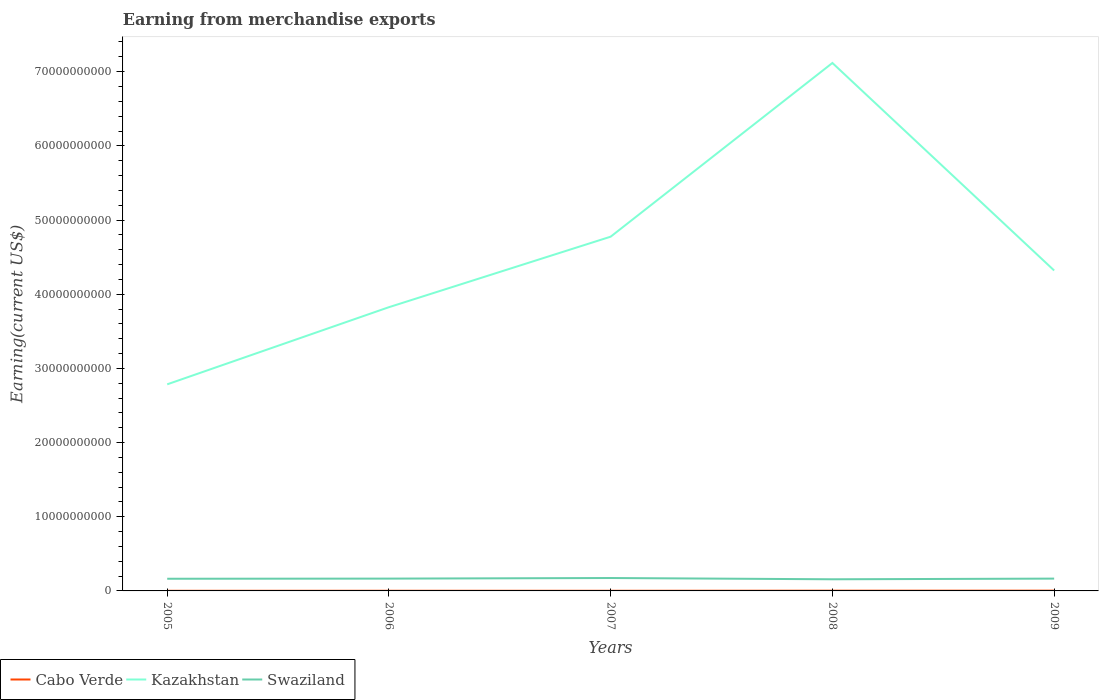Does the line corresponding to Kazakhstan intersect with the line corresponding to Swaziland?
Your response must be concise. No. Across all years, what is the maximum amount earned from merchandise exports in Kazakhstan?
Provide a short and direct response. 2.78e+1. What is the total amount earned from merchandise exports in Swaziland in the graph?
Your response must be concise. 7.00e+07. What is the difference between the highest and the second highest amount earned from merchandise exports in Kazakhstan?
Your answer should be compact. 4.33e+1. Is the amount earned from merchandise exports in Cabo Verde strictly greater than the amount earned from merchandise exports in Kazakhstan over the years?
Offer a terse response. Yes. How many lines are there?
Your answer should be compact. 3. Does the graph contain grids?
Give a very brief answer. No. Where does the legend appear in the graph?
Keep it short and to the point. Bottom left. How many legend labels are there?
Offer a terse response. 3. How are the legend labels stacked?
Your answer should be compact. Horizontal. What is the title of the graph?
Provide a succinct answer. Earning from merchandise exports. Does "High income: OECD" appear as one of the legend labels in the graph?
Your answer should be compact. No. What is the label or title of the Y-axis?
Offer a very short reply. Earning(current US$). What is the Earning(current US$) of Cabo Verde in 2005?
Your answer should be compact. 1.76e+07. What is the Earning(current US$) in Kazakhstan in 2005?
Your response must be concise. 2.78e+1. What is the Earning(current US$) of Swaziland in 2005?
Provide a short and direct response. 1.64e+09. What is the Earning(current US$) of Cabo Verde in 2006?
Ensure brevity in your answer.  2.07e+07. What is the Earning(current US$) in Kazakhstan in 2006?
Ensure brevity in your answer.  3.82e+1. What is the Earning(current US$) in Swaziland in 2006?
Offer a very short reply. 1.66e+09. What is the Earning(current US$) of Cabo Verde in 2007?
Offer a terse response. 1.92e+07. What is the Earning(current US$) in Kazakhstan in 2007?
Your response must be concise. 4.78e+1. What is the Earning(current US$) in Swaziland in 2007?
Keep it short and to the point. 1.74e+09. What is the Earning(current US$) in Cabo Verde in 2008?
Provide a short and direct response. 3.20e+07. What is the Earning(current US$) of Kazakhstan in 2008?
Keep it short and to the point. 7.12e+1. What is the Earning(current US$) in Swaziland in 2008?
Offer a very short reply. 1.57e+09. What is the Earning(current US$) in Cabo Verde in 2009?
Your response must be concise. 3.51e+07. What is the Earning(current US$) of Kazakhstan in 2009?
Your answer should be very brief. 4.32e+1. What is the Earning(current US$) in Swaziland in 2009?
Offer a terse response. 1.66e+09. Across all years, what is the maximum Earning(current US$) of Cabo Verde?
Your response must be concise. 3.51e+07. Across all years, what is the maximum Earning(current US$) in Kazakhstan?
Keep it short and to the point. 7.12e+1. Across all years, what is the maximum Earning(current US$) in Swaziland?
Offer a very short reply. 1.74e+09. Across all years, what is the minimum Earning(current US$) of Cabo Verde?
Your answer should be compact. 1.76e+07. Across all years, what is the minimum Earning(current US$) in Kazakhstan?
Provide a short and direct response. 2.78e+1. Across all years, what is the minimum Earning(current US$) in Swaziland?
Provide a succinct answer. 1.57e+09. What is the total Earning(current US$) in Cabo Verde in the graph?
Provide a succinct answer. 1.25e+08. What is the total Earning(current US$) in Kazakhstan in the graph?
Provide a short and direct response. 2.28e+11. What is the total Earning(current US$) in Swaziland in the graph?
Offer a very short reply. 8.27e+09. What is the difference between the Earning(current US$) of Cabo Verde in 2005 and that in 2006?
Offer a terse response. -3.04e+06. What is the difference between the Earning(current US$) of Kazakhstan in 2005 and that in 2006?
Provide a succinct answer. -1.04e+1. What is the difference between the Earning(current US$) of Swaziland in 2005 and that in 2006?
Give a very brief answer. -2.00e+07. What is the difference between the Earning(current US$) in Cabo Verde in 2005 and that in 2007?
Give a very brief answer. -1.60e+06. What is the difference between the Earning(current US$) in Kazakhstan in 2005 and that in 2007?
Make the answer very short. -1.99e+1. What is the difference between the Earning(current US$) of Swaziland in 2005 and that in 2007?
Offer a terse response. -1.00e+08. What is the difference between the Earning(current US$) of Cabo Verde in 2005 and that in 2008?
Offer a terse response. -1.44e+07. What is the difference between the Earning(current US$) in Kazakhstan in 2005 and that in 2008?
Your answer should be compact. -4.33e+1. What is the difference between the Earning(current US$) of Swaziland in 2005 and that in 2008?
Keep it short and to the point. 7.00e+07. What is the difference between the Earning(current US$) of Cabo Verde in 2005 and that in 2009?
Offer a very short reply. -1.75e+07. What is the difference between the Earning(current US$) in Kazakhstan in 2005 and that in 2009?
Your answer should be compact. -1.53e+1. What is the difference between the Earning(current US$) in Swaziland in 2005 and that in 2009?
Keep it short and to the point. -2.00e+07. What is the difference between the Earning(current US$) in Cabo Verde in 2006 and that in 2007?
Make the answer very short. 1.43e+06. What is the difference between the Earning(current US$) of Kazakhstan in 2006 and that in 2007?
Offer a very short reply. -9.50e+09. What is the difference between the Earning(current US$) of Swaziland in 2006 and that in 2007?
Keep it short and to the point. -8.00e+07. What is the difference between the Earning(current US$) of Cabo Verde in 2006 and that in 2008?
Your answer should be compact. -1.13e+07. What is the difference between the Earning(current US$) in Kazakhstan in 2006 and that in 2008?
Ensure brevity in your answer.  -3.29e+1. What is the difference between the Earning(current US$) in Swaziland in 2006 and that in 2008?
Offer a very short reply. 9.00e+07. What is the difference between the Earning(current US$) of Cabo Verde in 2006 and that in 2009?
Provide a succinct answer. -1.45e+07. What is the difference between the Earning(current US$) in Kazakhstan in 2006 and that in 2009?
Offer a terse response. -4.95e+09. What is the difference between the Earning(current US$) of Cabo Verde in 2007 and that in 2008?
Provide a short and direct response. -1.28e+07. What is the difference between the Earning(current US$) in Kazakhstan in 2007 and that in 2008?
Keep it short and to the point. -2.34e+1. What is the difference between the Earning(current US$) in Swaziland in 2007 and that in 2008?
Your response must be concise. 1.70e+08. What is the difference between the Earning(current US$) in Cabo Verde in 2007 and that in 2009?
Give a very brief answer. -1.59e+07. What is the difference between the Earning(current US$) in Kazakhstan in 2007 and that in 2009?
Make the answer very short. 4.56e+09. What is the difference between the Earning(current US$) of Swaziland in 2007 and that in 2009?
Offer a very short reply. 8.00e+07. What is the difference between the Earning(current US$) of Cabo Verde in 2008 and that in 2009?
Your answer should be compact. -3.14e+06. What is the difference between the Earning(current US$) in Kazakhstan in 2008 and that in 2009?
Your answer should be very brief. 2.80e+1. What is the difference between the Earning(current US$) of Swaziland in 2008 and that in 2009?
Make the answer very short. -9.00e+07. What is the difference between the Earning(current US$) of Cabo Verde in 2005 and the Earning(current US$) of Kazakhstan in 2006?
Offer a terse response. -3.82e+1. What is the difference between the Earning(current US$) of Cabo Verde in 2005 and the Earning(current US$) of Swaziland in 2006?
Make the answer very short. -1.64e+09. What is the difference between the Earning(current US$) in Kazakhstan in 2005 and the Earning(current US$) in Swaziland in 2006?
Offer a terse response. 2.62e+1. What is the difference between the Earning(current US$) of Cabo Verde in 2005 and the Earning(current US$) of Kazakhstan in 2007?
Ensure brevity in your answer.  -4.77e+1. What is the difference between the Earning(current US$) in Cabo Verde in 2005 and the Earning(current US$) in Swaziland in 2007?
Your answer should be very brief. -1.72e+09. What is the difference between the Earning(current US$) in Kazakhstan in 2005 and the Earning(current US$) in Swaziland in 2007?
Your answer should be compact. 2.61e+1. What is the difference between the Earning(current US$) in Cabo Verde in 2005 and the Earning(current US$) in Kazakhstan in 2008?
Your answer should be very brief. -7.12e+1. What is the difference between the Earning(current US$) in Cabo Verde in 2005 and the Earning(current US$) in Swaziland in 2008?
Offer a very short reply. -1.55e+09. What is the difference between the Earning(current US$) in Kazakhstan in 2005 and the Earning(current US$) in Swaziland in 2008?
Give a very brief answer. 2.63e+1. What is the difference between the Earning(current US$) in Cabo Verde in 2005 and the Earning(current US$) in Kazakhstan in 2009?
Make the answer very short. -4.32e+1. What is the difference between the Earning(current US$) in Cabo Verde in 2005 and the Earning(current US$) in Swaziland in 2009?
Your response must be concise. -1.64e+09. What is the difference between the Earning(current US$) in Kazakhstan in 2005 and the Earning(current US$) in Swaziland in 2009?
Your response must be concise. 2.62e+1. What is the difference between the Earning(current US$) in Cabo Verde in 2006 and the Earning(current US$) in Kazakhstan in 2007?
Your answer should be very brief. -4.77e+1. What is the difference between the Earning(current US$) in Cabo Verde in 2006 and the Earning(current US$) in Swaziland in 2007?
Make the answer very short. -1.72e+09. What is the difference between the Earning(current US$) in Kazakhstan in 2006 and the Earning(current US$) in Swaziland in 2007?
Provide a short and direct response. 3.65e+1. What is the difference between the Earning(current US$) of Cabo Verde in 2006 and the Earning(current US$) of Kazakhstan in 2008?
Offer a terse response. -7.12e+1. What is the difference between the Earning(current US$) of Cabo Verde in 2006 and the Earning(current US$) of Swaziland in 2008?
Your answer should be very brief. -1.55e+09. What is the difference between the Earning(current US$) in Kazakhstan in 2006 and the Earning(current US$) in Swaziland in 2008?
Make the answer very short. 3.67e+1. What is the difference between the Earning(current US$) of Cabo Verde in 2006 and the Earning(current US$) of Kazakhstan in 2009?
Offer a very short reply. -4.32e+1. What is the difference between the Earning(current US$) of Cabo Verde in 2006 and the Earning(current US$) of Swaziland in 2009?
Offer a terse response. -1.64e+09. What is the difference between the Earning(current US$) of Kazakhstan in 2006 and the Earning(current US$) of Swaziland in 2009?
Provide a short and direct response. 3.66e+1. What is the difference between the Earning(current US$) of Cabo Verde in 2007 and the Earning(current US$) of Kazakhstan in 2008?
Offer a terse response. -7.12e+1. What is the difference between the Earning(current US$) of Cabo Verde in 2007 and the Earning(current US$) of Swaziland in 2008?
Offer a terse response. -1.55e+09. What is the difference between the Earning(current US$) of Kazakhstan in 2007 and the Earning(current US$) of Swaziland in 2008?
Keep it short and to the point. 4.62e+1. What is the difference between the Earning(current US$) in Cabo Verde in 2007 and the Earning(current US$) in Kazakhstan in 2009?
Provide a succinct answer. -4.32e+1. What is the difference between the Earning(current US$) in Cabo Verde in 2007 and the Earning(current US$) in Swaziland in 2009?
Your response must be concise. -1.64e+09. What is the difference between the Earning(current US$) of Kazakhstan in 2007 and the Earning(current US$) of Swaziland in 2009?
Provide a succinct answer. 4.61e+1. What is the difference between the Earning(current US$) of Cabo Verde in 2008 and the Earning(current US$) of Kazakhstan in 2009?
Ensure brevity in your answer.  -4.32e+1. What is the difference between the Earning(current US$) of Cabo Verde in 2008 and the Earning(current US$) of Swaziland in 2009?
Your answer should be compact. -1.63e+09. What is the difference between the Earning(current US$) in Kazakhstan in 2008 and the Earning(current US$) in Swaziland in 2009?
Provide a succinct answer. 6.95e+1. What is the average Earning(current US$) of Cabo Verde per year?
Your answer should be very brief. 2.49e+07. What is the average Earning(current US$) of Kazakhstan per year?
Provide a succinct answer. 4.56e+1. What is the average Earning(current US$) of Swaziland per year?
Provide a short and direct response. 1.65e+09. In the year 2005, what is the difference between the Earning(current US$) of Cabo Verde and Earning(current US$) of Kazakhstan?
Make the answer very short. -2.78e+1. In the year 2005, what is the difference between the Earning(current US$) of Cabo Verde and Earning(current US$) of Swaziland?
Ensure brevity in your answer.  -1.62e+09. In the year 2005, what is the difference between the Earning(current US$) of Kazakhstan and Earning(current US$) of Swaziland?
Make the answer very short. 2.62e+1. In the year 2006, what is the difference between the Earning(current US$) in Cabo Verde and Earning(current US$) in Kazakhstan?
Offer a very short reply. -3.82e+1. In the year 2006, what is the difference between the Earning(current US$) in Cabo Verde and Earning(current US$) in Swaziland?
Offer a very short reply. -1.64e+09. In the year 2006, what is the difference between the Earning(current US$) of Kazakhstan and Earning(current US$) of Swaziland?
Ensure brevity in your answer.  3.66e+1. In the year 2007, what is the difference between the Earning(current US$) of Cabo Verde and Earning(current US$) of Kazakhstan?
Offer a terse response. -4.77e+1. In the year 2007, what is the difference between the Earning(current US$) of Cabo Verde and Earning(current US$) of Swaziland?
Give a very brief answer. -1.72e+09. In the year 2007, what is the difference between the Earning(current US$) of Kazakhstan and Earning(current US$) of Swaziland?
Offer a terse response. 4.60e+1. In the year 2008, what is the difference between the Earning(current US$) of Cabo Verde and Earning(current US$) of Kazakhstan?
Provide a succinct answer. -7.11e+1. In the year 2008, what is the difference between the Earning(current US$) of Cabo Verde and Earning(current US$) of Swaziland?
Keep it short and to the point. -1.54e+09. In the year 2008, what is the difference between the Earning(current US$) of Kazakhstan and Earning(current US$) of Swaziland?
Your answer should be very brief. 6.96e+1. In the year 2009, what is the difference between the Earning(current US$) in Cabo Verde and Earning(current US$) in Kazakhstan?
Make the answer very short. -4.32e+1. In the year 2009, what is the difference between the Earning(current US$) in Cabo Verde and Earning(current US$) in Swaziland?
Provide a short and direct response. -1.62e+09. In the year 2009, what is the difference between the Earning(current US$) of Kazakhstan and Earning(current US$) of Swaziland?
Offer a terse response. 4.15e+1. What is the ratio of the Earning(current US$) in Cabo Verde in 2005 to that in 2006?
Keep it short and to the point. 0.85. What is the ratio of the Earning(current US$) of Kazakhstan in 2005 to that in 2006?
Your response must be concise. 0.73. What is the ratio of the Earning(current US$) in Cabo Verde in 2005 to that in 2007?
Your response must be concise. 0.92. What is the ratio of the Earning(current US$) of Kazakhstan in 2005 to that in 2007?
Your answer should be very brief. 0.58. What is the ratio of the Earning(current US$) of Swaziland in 2005 to that in 2007?
Your answer should be very brief. 0.94. What is the ratio of the Earning(current US$) in Cabo Verde in 2005 to that in 2008?
Provide a short and direct response. 0.55. What is the ratio of the Earning(current US$) in Kazakhstan in 2005 to that in 2008?
Your answer should be very brief. 0.39. What is the ratio of the Earning(current US$) of Swaziland in 2005 to that in 2008?
Provide a succinct answer. 1.04. What is the ratio of the Earning(current US$) of Cabo Verde in 2005 to that in 2009?
Ensure brevity in your answer.  0.5. What is the ratio of the Earning(current US$) of Kazakhstan in 2005 to that in 2009?
Provide a short and direct response. 0.64. What is the ratio of the Earning(current US$) of Cabo Verde in 2006 to that in 2007?
Ensure brevity in your answer.  1.07. What is the ratio of the Earning(current US$) in Kazakhstan in 2006 to that in 2007?
Provide a short and direct response. 0.8. What is the ratio of the Earning(current US$) of Swaziland in 2006 to that in 2007?
Your answer should be compact. 0.95. What is the ratio of the Earning(current US$) of Cabo Verde in 2006 to that in 2008?
Your answer should be compact. 0.65. What is the ratio of the Earning(current US$) of Kazakhstan in 2006 to that in 2008?
Offer a terse response. 0.54. What is the ratio of the Earning(current US$) of Swaziland in 2006 to that in 2008?
Your answer should be very brief. 1.06. What is the ratio of the Earning(current US$) in Cabo Verde in 2006 to that in 2009?
Keep it short and to the point. 0.59. What is the ratio of the Earning(current US$) of Kazakhstan in 2006 to that in 2009?
Provide a short and direct response. 0.89. What is the ratio of the Earning(current US$) in Swaziland in 2006 to that in 2009?
Your answer should be very brief. 1. What is the ratio of the Earning(current US$) of Cabo Verde in 2007 to that in 2008?
Ensure brevity in your answer.  0.6. What is the ratio of the Earning(current US$) in Kazakhstan in 2007 to that in 2008?
Provide a succinct answer. 0.67. What is the ratio of the Earning(current US$) of Swaziland in 2007 to that in 2008?
Your answer should be compact. 1.11. What is the ratio of the Earning(current US$) of Cabo Verde in 2007 to that in 2009?
Ensure brevity in your answer.  0.55. What is the ratio of the Earning(current US$) of Kazakhstan in 2007 to that in 2009?
Make the answer very short. 1.11. What is the ratio of the Earning(current US$) of Swaziland in 2007 to that in 2009?
Your response must be concise. 1.05. What is the ratio of the Earning(current US$) of Cabo Verde in 2008 to that in 2009?
Provide a succinct answer. 0.91. What is the ratio of the Earning(current US$) of Kazakhstan in 2008 to that in 2009?
Give a very brief answer. 1.65. What is the ratio of the Earning(current US$) of Swaziland in 2008 to that in 2009?
Your response must be concise. 0.95. What is the difference between the highest and the second highest Earning(current US$) in Cabo Verde?
Your answer should be compact. 3.14e+06. What is the difference between the highest and the second highest Earning(current US$) in Kazakhstan?
Your response must be concise. 2.34e+1. What is the difference between the highest and the second highest Earning(current US$) of Swaziland?
Ensure brevity in your answer.  8.00e+07. What is the difference between the highest and the lowest Earning(current US$) in Cabo Verde?
Provide a succinct answer. 1.75e+07. What is the difference between the highest and the lowest Earning(current US$) of Kazakhstan?
Your response must be concise. 4.33e+1. What is the difference between the highest and the lowest Earning(current US$) of Swaziland?
Your answer should be compact. 1.70e+08. 